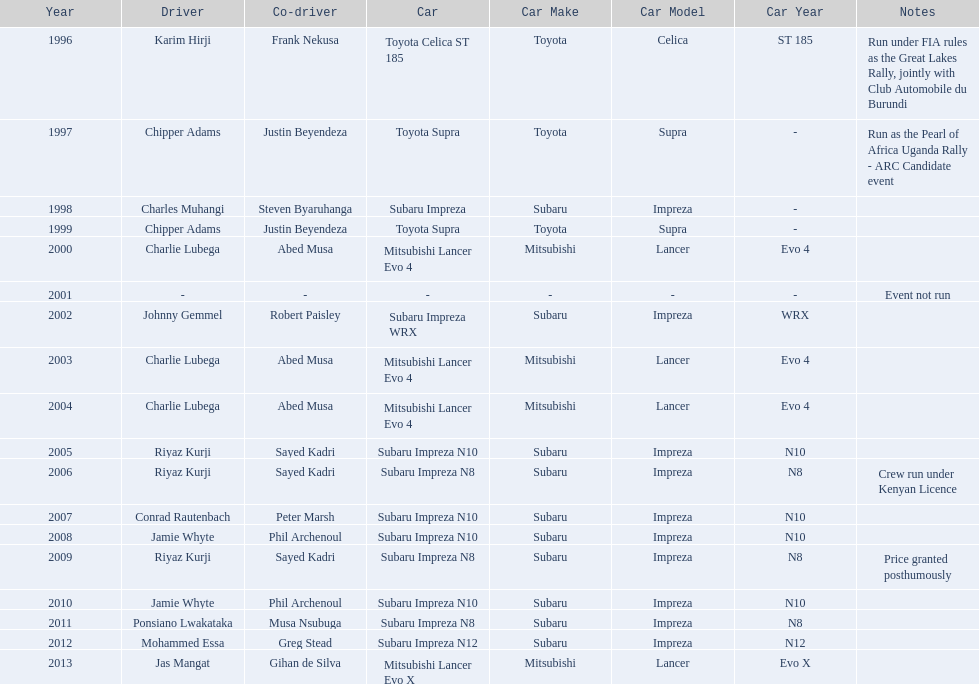Would you mind parsing the complete table? {'header': ['Year', 'Driver', 'Co-driver', 'Car', 'Car Make', 'Car Model', 'Car Year', 'Notes'], 'rows': [['1996', 'Karim Hirji', 'Frank Nekusa', 'Toyota Celica ST 185', 'Toyota', 'Celica', 'ST 185', 'Run under FIA rules as the Great Lakes Rally, jointly with Club Automobile du Burundi'], ['1997', 'Chipper Adams', 'Justin Beyendeza', 'Toyota Supra', 'Toyota', 'Supra', '-', 'Run as the Pearl of Africa Uganda Rally - ARC Candidate event'], ['1998', 'Charles Muhangi', 'Steven Byaruhanga', 'Subaru Impreza', 'Subaru', 'Impreza', '-', ''], ['1999', 'Chipper Adams', 'Justin Beyendeza', 'Toyota Supra', 'Toyota', 'Supra', '-', ''], ['2000', 'Charlie Lubega', 'Abed Musa', 'Mitsubishi Lancer Evo 4', 'Mitsubishi', 'Lancer', 'Evo 4', ''], ['2001', '-', '-', '-', '-', '-', '-', 'Event not run'], ['2002', 'Johnny Gemmel', 'Robert Paisley', 'Subaru Impreza WRX', 'Subaru', 'Impreza', 'WRX', ''], ['2003', 'Charlie Lubega', 'Abed Musa', 'Mitsubishi Lancer Evo 4', 'Mitsubishi', 'Lancer', 'Evo 4', ''], ['2004', 'Charlie Lubega', 'Abed Musa', 'Mitsubishi Lancer Evo 4', 'Mitsubishi', 'Lancer', 'Evo 4', ''], ['2005', 'Riyaz Kurji', 'Sayed Kadri', 'Subaru Impreza N10', 'Subaru', 'Impreza', 'N10', ''], ['2006', 'Riyaz Kurji', 'Sayed Kadri', 'Subaru Impreza N8', 'Subaru', 'Impreza', 'N8', 'Crew run under Kenyan Licence'], ['2007', 'Conrad Rautenbach', 'Peter Marsh', 'Subaru Impreza N10', 'Subaru', 'Impreza', 'N10', ''], ['2008', 'Jamie Whyte', 'Phil Archenoul', 'Subaru Impreza N10', 'Subaru', 'Impreza', 'N10', ''], ['2009', 'Riyaz Kurji', 'Sayed Kadri', 'Subaru Impreza N8', 'Subaru', 'Impreza', 'N8', 'Price granted posthumously'], ['2010', 'Jamie Whyte', 'Phil Archenoul', 'Subaru Impreza N10', 'Subaru', 'Impreza', 'N10', ''], ['2011', 'Ponsiano Lwakataka', 'Musa Nsubuga', 'Subaru Impreza N8', 'Subaru', 'Impreza', 'N8', ''], ['2012', 'Mohammed Essa', 'Greg Stead', 'Subaru Impreza N12', 'Subaru', 'Impreza', 'N12', ''], ['2013', 'Jas Mangat', 'Gihan de Silva', 'Mitsubishi Lancer Evo X', 'Mitsubishi', 'Lancer', 'Evo X', '']]} How many times was charlie lubega a driver? 3. 